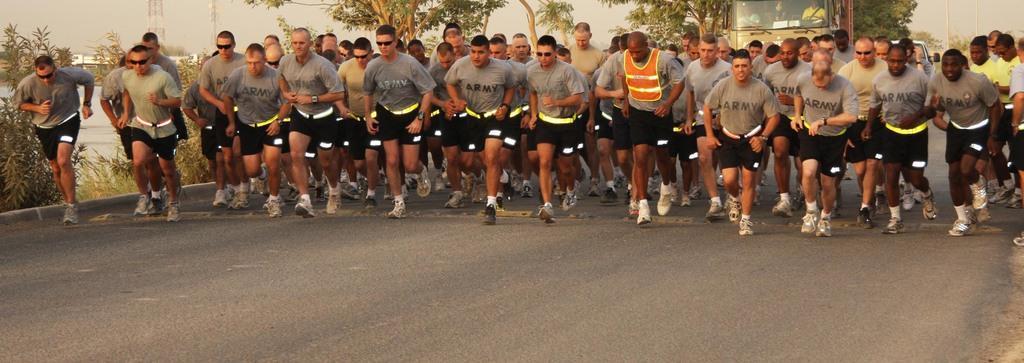How would you summarize this image in a sentence or two? In the picture there are people running on the road. In the background there are trees, buildings, poles, towers and a vehicle. 